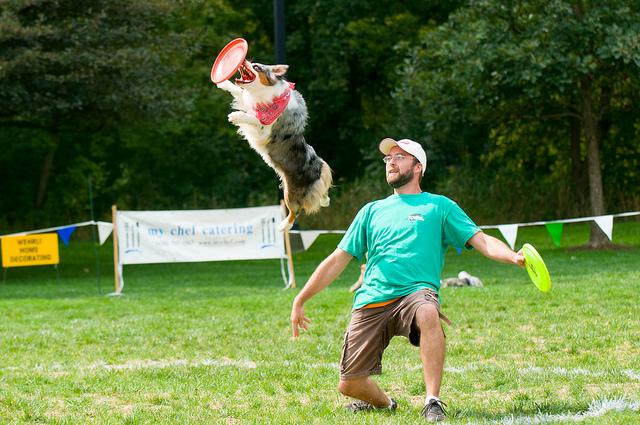What kind of service does the white sign promise? catering 